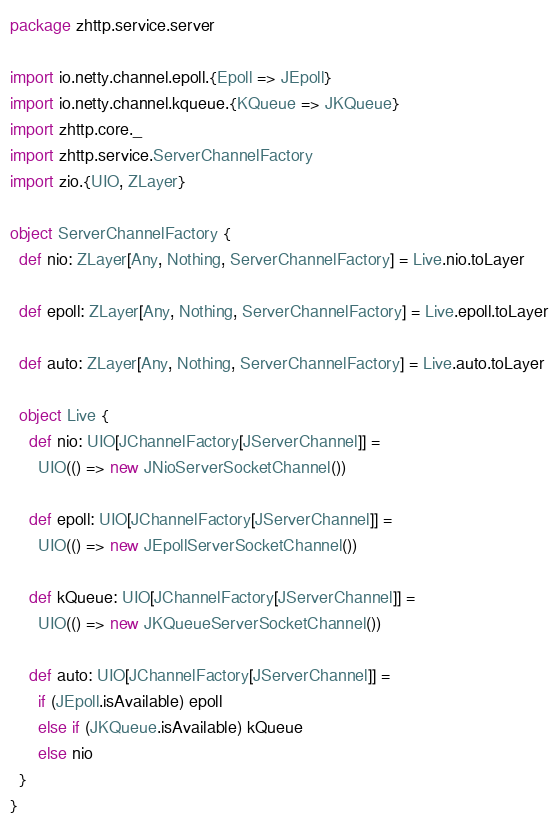<code> <loc_0><loc_0><loc_500><loc_500><_Scala_>package zhttp.service.server

import io.netty.channel.epoll.{Epoll => JEpoll}
import io.netty.channel.kqueue.{KQueue => JKQueue}
import zhttp.core._
import zhttp.service.ServerChannelFactory
import zio.{UIO, ZLayer}

object ServerChannelFactory {
  def nio: ZLayer[Any, Nothing, ServerChannelFactory] = Live.nio.toLayer

  def epoll: ZLayer[Any, Nothing, ServerChannelFactory] = Live.epoll.toLayer

  def auto: ZLayer[Any, Nothing, ServerChannelFactory] = Live.auto.toLayer

  object Live {
    def nio: UIO[JChannelFactory[JServerChannel]] =
      UIO(() => new JNioServerSocketChannel())

    def epoll: UIO[JChannelFactory[JServerChannel]] =
      UIO(() => new JEpollServerSocketChannel())

    def kQueue: UIO[JChannelFactory[JServerChannel]] =
      UIO(() => new JKQueueServerSocketChannel())

    def auto: UIO[JChannelFactory[JServerChannel]] =
      if (JEpoll.isAvailable) epoll
      else if (JKQueue.isAvailable) kQueue
      else nio
  }
}
</code> 